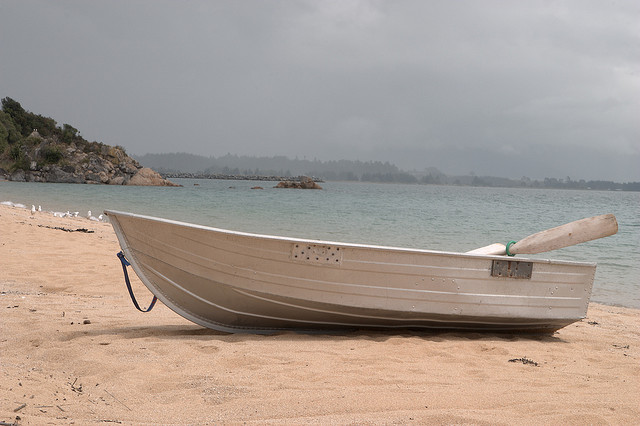<image>Which boat has an engine? It is unknown which boat has an engine. There is no clear indication in the image. Which boat has an engine? It is ambiguous which boat has an engine. None of the boats in the image show any signs of an engine. 